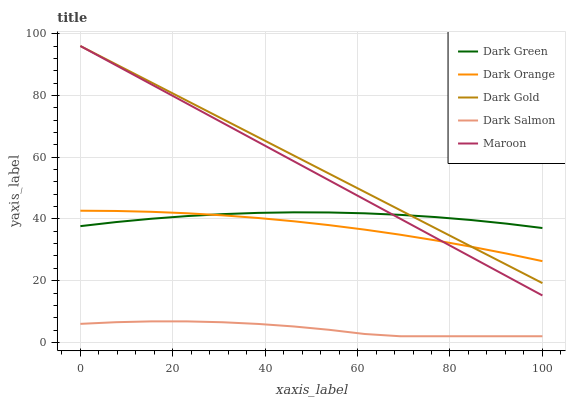Does Dark Salmon have the minimum area under the curve?
Answer yes or no. Yes. Does Dark Gold have the maximum area under the curve?
Answer yes or no. Yes. Does Dark Gold have the minimum area under the curve?
Answer yes or no. No. Does Dark Salmon have the maximum area under the curve?
Answer yes or no. No. Is Dark Gold the smoothest?
Answer yes or no. Yes. Is Dark Salmon the roughest?
Answer yes or no. Yes. Is Dark Salmon the smoothest?
Answer yes or no. No. Is Dark Gold the roughest?
Answer yes or no. No. Does Dark Salmon have the lowest value?
Answer yes or no. Yes. Does Dark Gold have the lowest value?
Answer yes or no. No. Does Maroon have the highest value?
Answer yes or no. Yes. Does Dark Salmon have the highest value?
Answer yes or no. No. Is Dark Salmon less than Maroon?
Answer yes or no. Yes. Is Dark Green greater than Dark Salmon?
Answer yes or no. Yes. Does Dark Green intersect Dark Gold?
Answer yes or no. Yes. Is Dark Green less than Dark Gold?
Answer yes or no. No. Is Dark Green greater than Dark Gold?
Answer yes or no. No. Does Dark Salmon intersect Maroon?
Answer yes or no. No. 